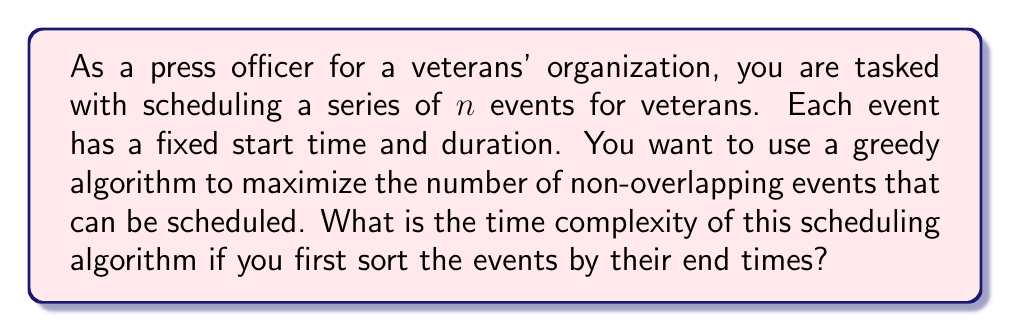What is the answer to this math problem? To analyze the time complexity of this scheduling algorithm, let's break it down into steps:

1. Sorting the events:
   The first step is to sort all $n$ events based on their end times. Using an efficient sorting algorithm like Merge Sort or Heap Sort, this operation has a time complexity of $O(n \log n)$.

2. Greedy selection:
   After sorting, we iterate through the sorted list of events once, selecting non-overlapping events:
   - Select the first event (earliest end time)
   - For each subsequent event, check if its start time is after the end time of the previously selected event
   - If it doesn't overlap, select it and update the current end time

   This iteration through the sorted list takes $O(n)$ time.

3. Overall time complexity:
   The total time complexity is the sum of the sorting step and the greedy selection step:
   
   $$T(n) = O(n \log n) + O(n)$$
   
   Since $O(n \log n)$ grows faster than $O(n)$ for large $n$, we can simplify this to:
   
   $$T(n) = O(n \log n)$$

This algorithm is efficient for scheduling a large number of veterans' events, as it allows you to find the maximum number of non-overlapping events in $O(n \log n)$ time.
Answer: $O(n \log n)$ 